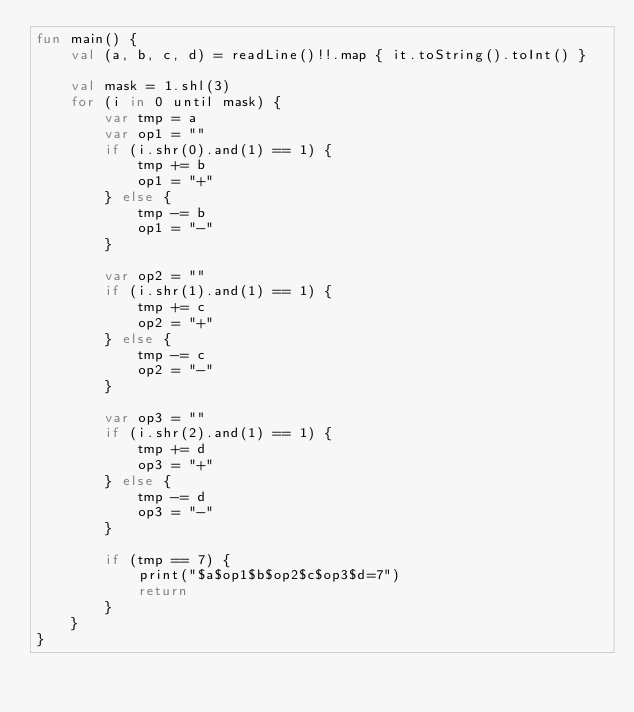Convert code to text. <code><loc_0><loc_0><loc_500><loc_500><_Kotlin_>fun main() {
    val (a, b, c, d) = readLine()!!.map { it.toString().toInt() }

    val mask = 1.shl(3)
    for (i in 0 until mask) {
        var tmp = a
        var op1 = ""
        if (i.shr(0).and(1) == 1) {
            tmp += b
            op1 = "+"
        } else {
            tmp -= b
            op1 = "-"
        }

        var op2 = ""
        if (i.shr(1).and(1) == 1) {
            tmp += c
            op2 = "+"
        } else {
            tmp -= c
            op2 = "-"
        }

        var op3 = ""
        if (i.shr(2).and(1) == 1) {
            tmp += d
            op3 = "+"
        } else {
            tmp -= d
            op3 = "-"
        }

        if (tmp == 7) {
            print("$a$op1$b$op2$c$op3$d=7")
            return
        }
    }
}
</code> 